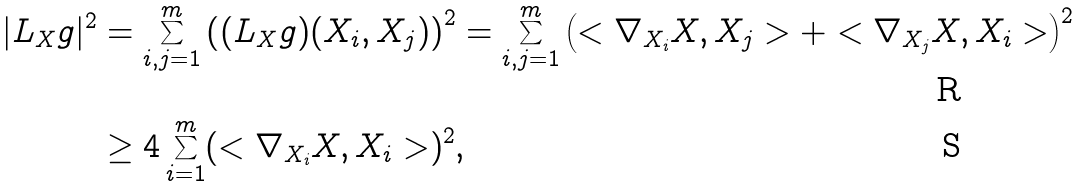<formula> <loc_0><loc_0><loc_500><loc_500>| L _ { X } g | ^ { 2 } & = \sum _ { i , j = 1 } ^ { m } \left ( ( L _ { X } g ) ( X _ { i } , X _ { j } ) \right ) ^ { 2 } = \sum _ { i , j = 1 } ^ { m } \left ( < \nabla _ { X _ { i } } X , X _ { j } > + < \nabla _ { X _ { j } } X , X _ { i } > \right ) ^ { 2 } \\ & \geq 4 \sum _ { i = 1 } ^ { m } ( < \nabla _ { X _ { i } } X , X _ { i } > ) ^ { 2 } ,</formula> 